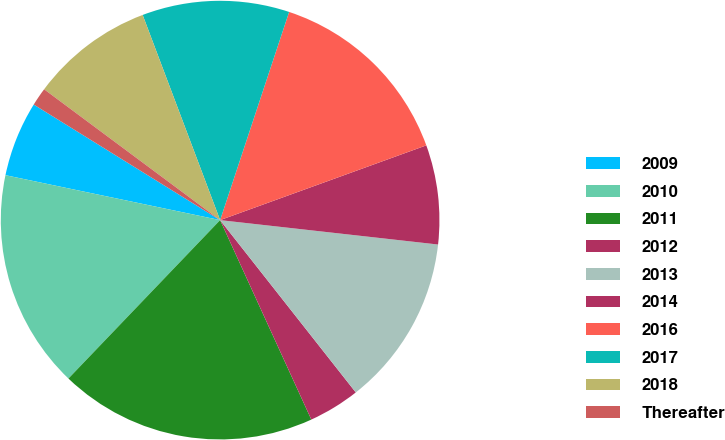Convert chart to OTSL. <chart><loc_0><loc_0><loc_500><loc_500><pie_chart><fcel>2009<fcel>2010<fcel>2011<fcel>2012<fcel>2013<fcel>2014<fcel>2016<fcel>2017<fcel>2018<fcel>Thereafter<nl><fcel>5.55%<fcel>16.13%<fcel>18.98%<fcel>3.79%<fcel>12.61%<fcel>7.31%<fcel>14.37%<fcel>10.84%<fcel>9.08%<fcel>1.34%<nl></chart> 